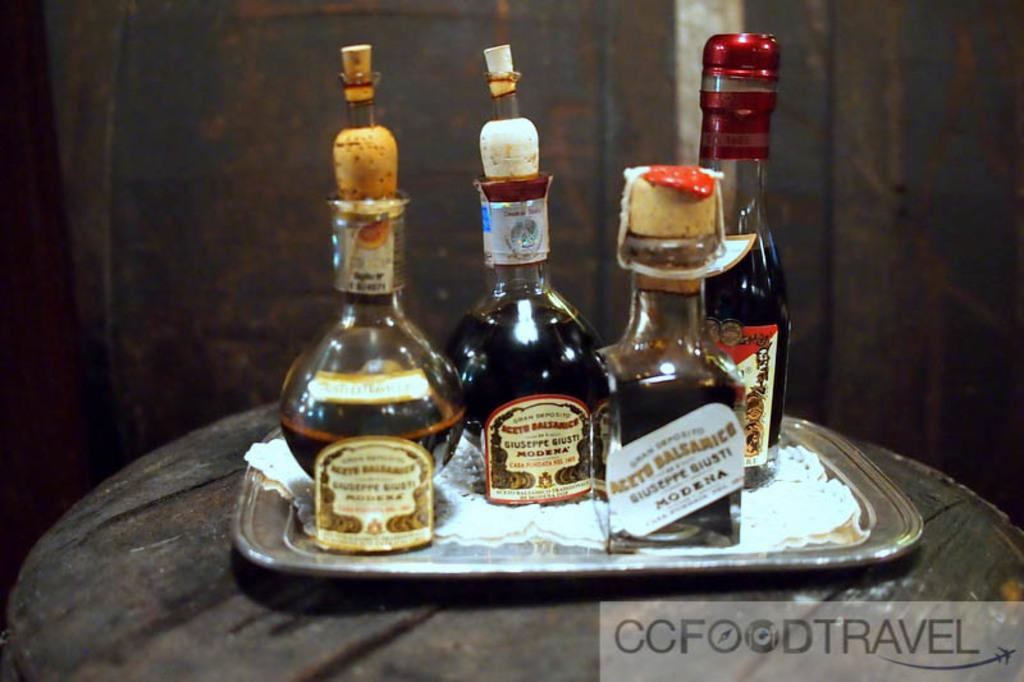<image>
Write a terse but informative summary of the picture. a silver tray with bottles of Acete Balsamico from Modena 